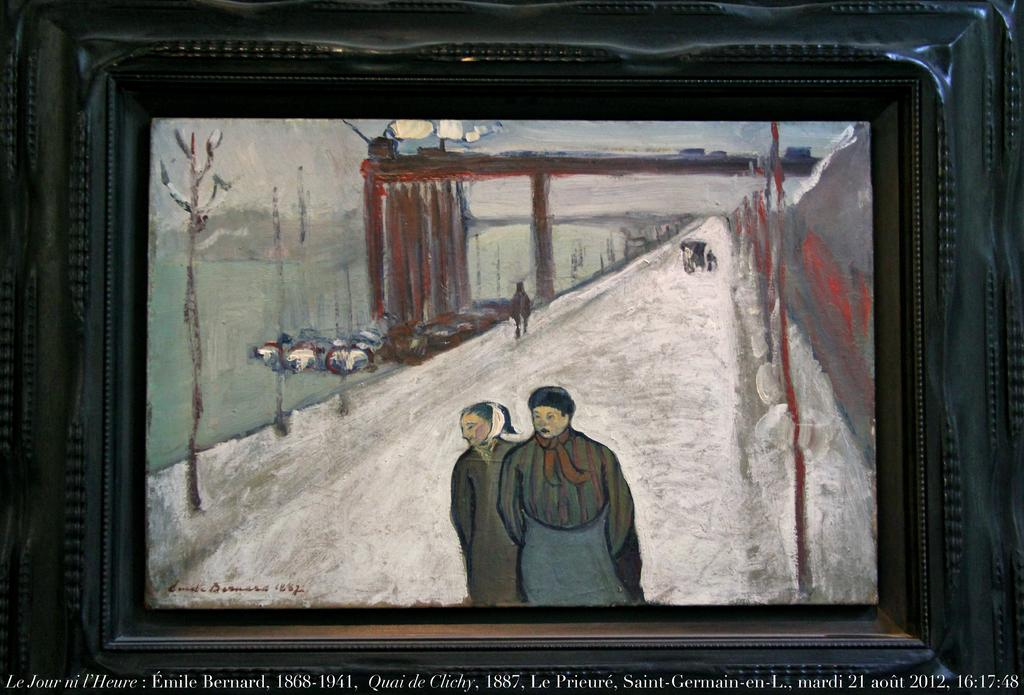<image>
Write a terse but informative summary of the picture. A painting created in 1882 by Emile Bernard. 